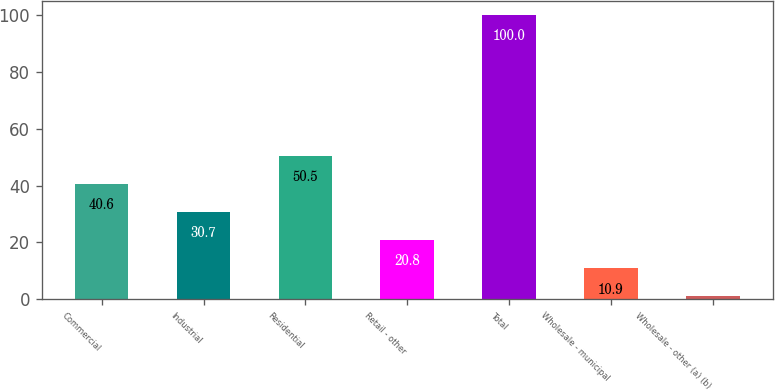Convert chart to OTSL. <chart><loc_0><loc_0><loc_500><loc_500><bar_chart><fcel>Commercial<fcel>Industrial<fcel>Residential<fcel>Retail - other<fcel>Total<fcel>Wholesale - municipal<fcel>Wholesale - other (a) (b)<nl><fcel>40.6<fcel>30.7<fcel>50.5<fcel>20.8<fcel>100<fcel>10.9<fcel>1<nl></chart> 